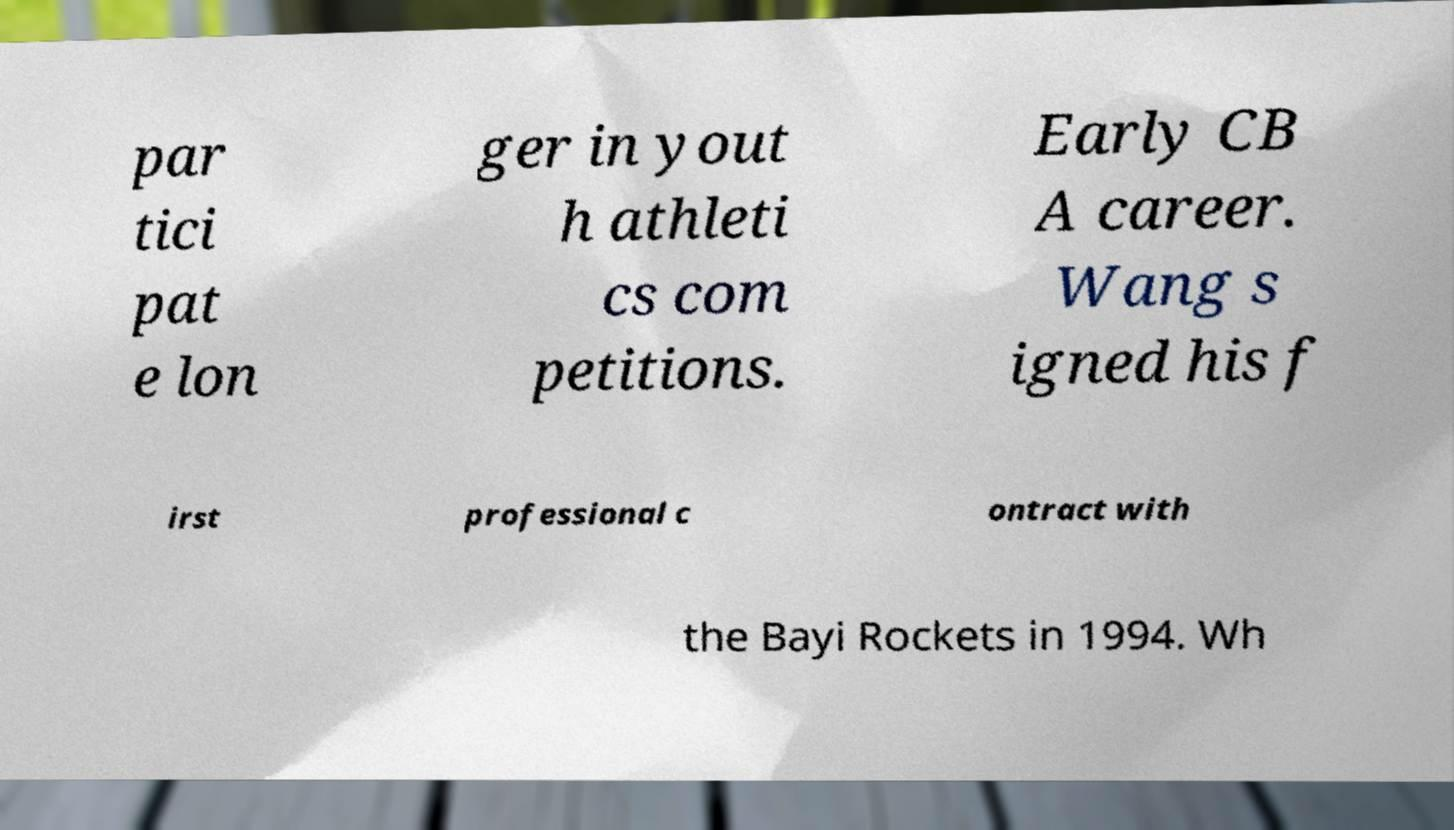I need the written content from this picture converted into text. Can you do that? par tici pat e lon ger in yout h athleti cs com petitions. Early CB A career. Wang s igned his f irst professional c ontract with the Bayi Rockets in 1994. Wh 